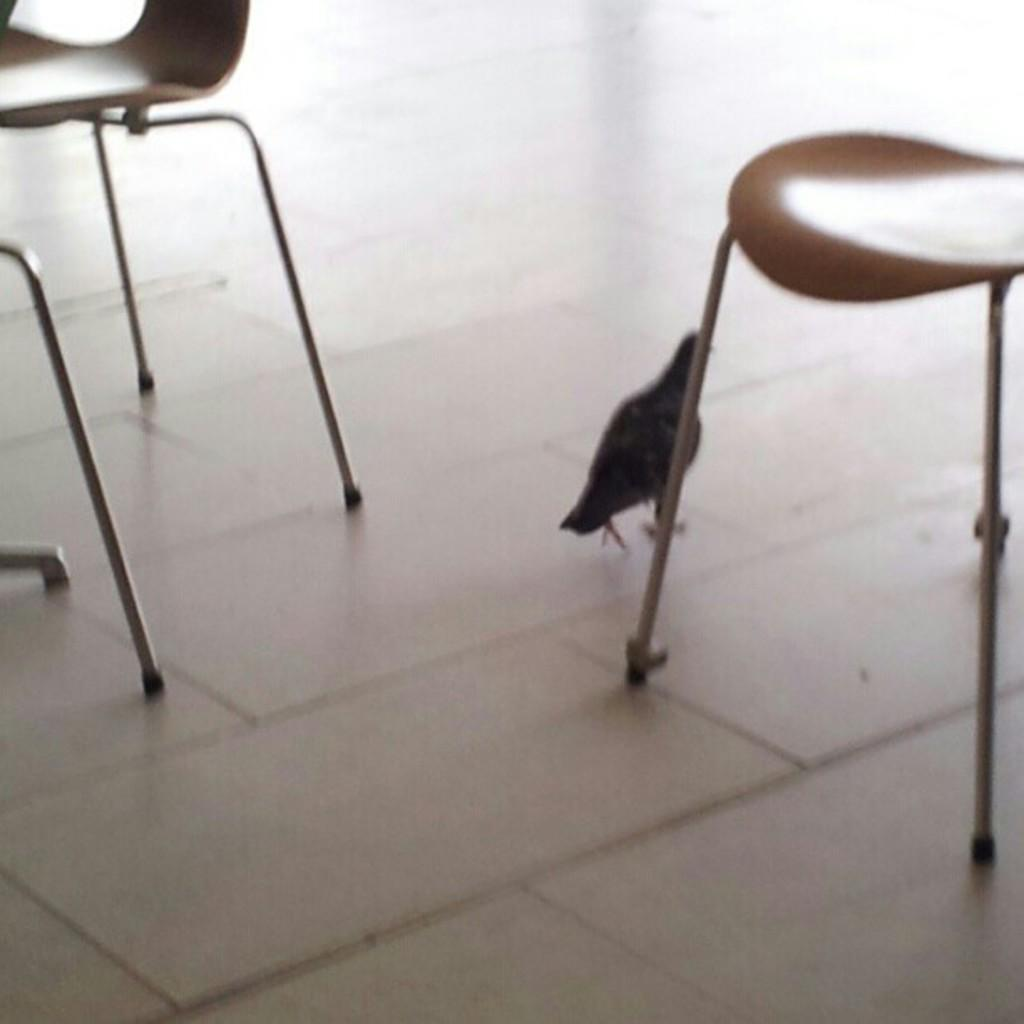How many chairs are visible in the image? There are two chairs in the image. What is present on the floor in the image? There is a bird on the floor in the image. How many clovers are visible on the chairs in the image? There are no clovers present on the chairs in the image. What type of bit is being used by the bird in the image? There is no bit present in the image, as it features a bird on the floor and birds do not use bits. 